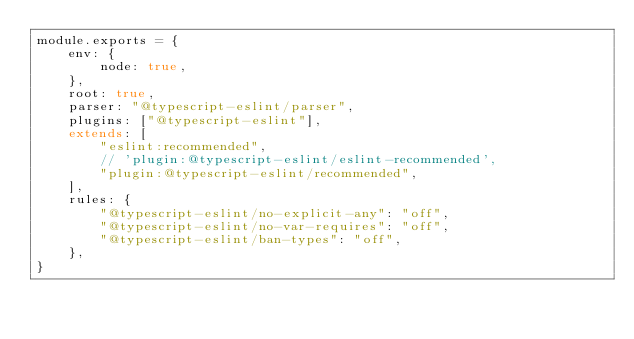<code> <loc_0><loc_0><loc_500><loc_500><_JavaScript_>module.exports = {
    env: {
        node: true,
    },
    root: true,
    parser: "@typescript-eslint/parser",
    plugins: ["@typescript-eslint"],
    extends: [
        "eslint:recommended",
        // 'plugin:@typescript-eslint/eslint-recommended',
        "plugin:@typescript-eslint/recommended",
    ],
    rules: {
        "@typescript-eslint/no-explicit-any": "off",
        "@typescript-eslint/no-var-requires": "off",
        "@typescript-eslint/ban-types": "off",
    },
}
</code> 